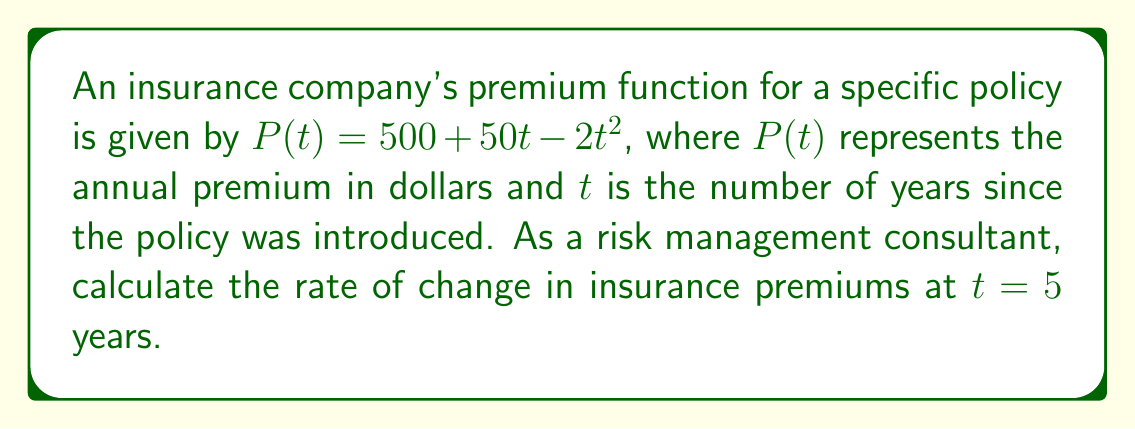What is the answer to this math problem? To find the rate of change in insurance premiums at a specific point in time, we need to calculate the derivative of the premium function and evaluate it at the given time.

1. Given premium function: $P(t) = 500 + 50t - 2t^2$

2. Calculate the derivative $P'(t)$:
   $P'(t) = \frac{d}{dt}(500 + 50t - 2t^2)$
   $P'(t) = 0 + 50 - 4t$ (using the power rule and constant rule of differentiation)
   $P'(t) = 50 - 4t$

3. Evaluate $P'(t)$ at $t = 5$:
   $P'(5) = 50 - 4(5)$
   $P'(5) = 50 - 20$
   $P'(5) = 30$

The rate of change in insurance premiums at $t = 5$ years is $30 dollars per year.

This positive value indicates that the premiums are still increasing at this point, but at a slower rate than initially. As a risk management consultant, you might advise the company to monitor this trend and adjust their pricing strategy accordingly to maintain competitiveness while ensuring adequate risk coverage.
Answer: $30 \text{ dollars per year}$ 